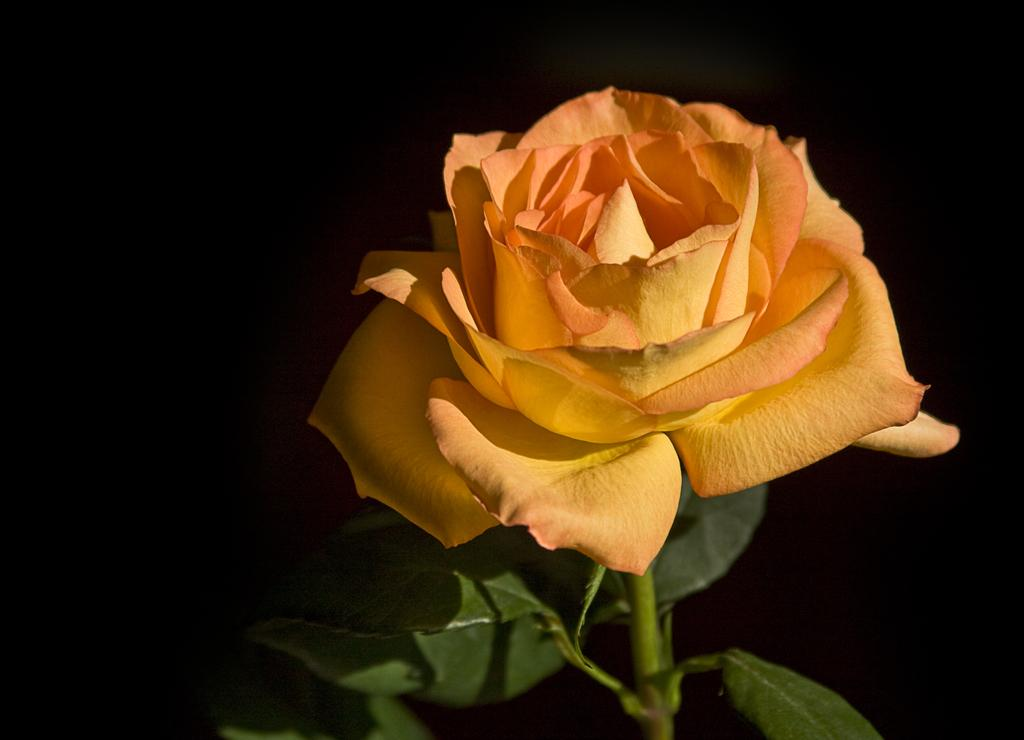What type of flower is in the picture? There is a rose flower in the picture. What else can be seen below the rose flower? There are leaves below the rose flower. How many friends are holding the card in the picture? There are no friends or cards present in the picture; it only features a rose flower and leaves. 